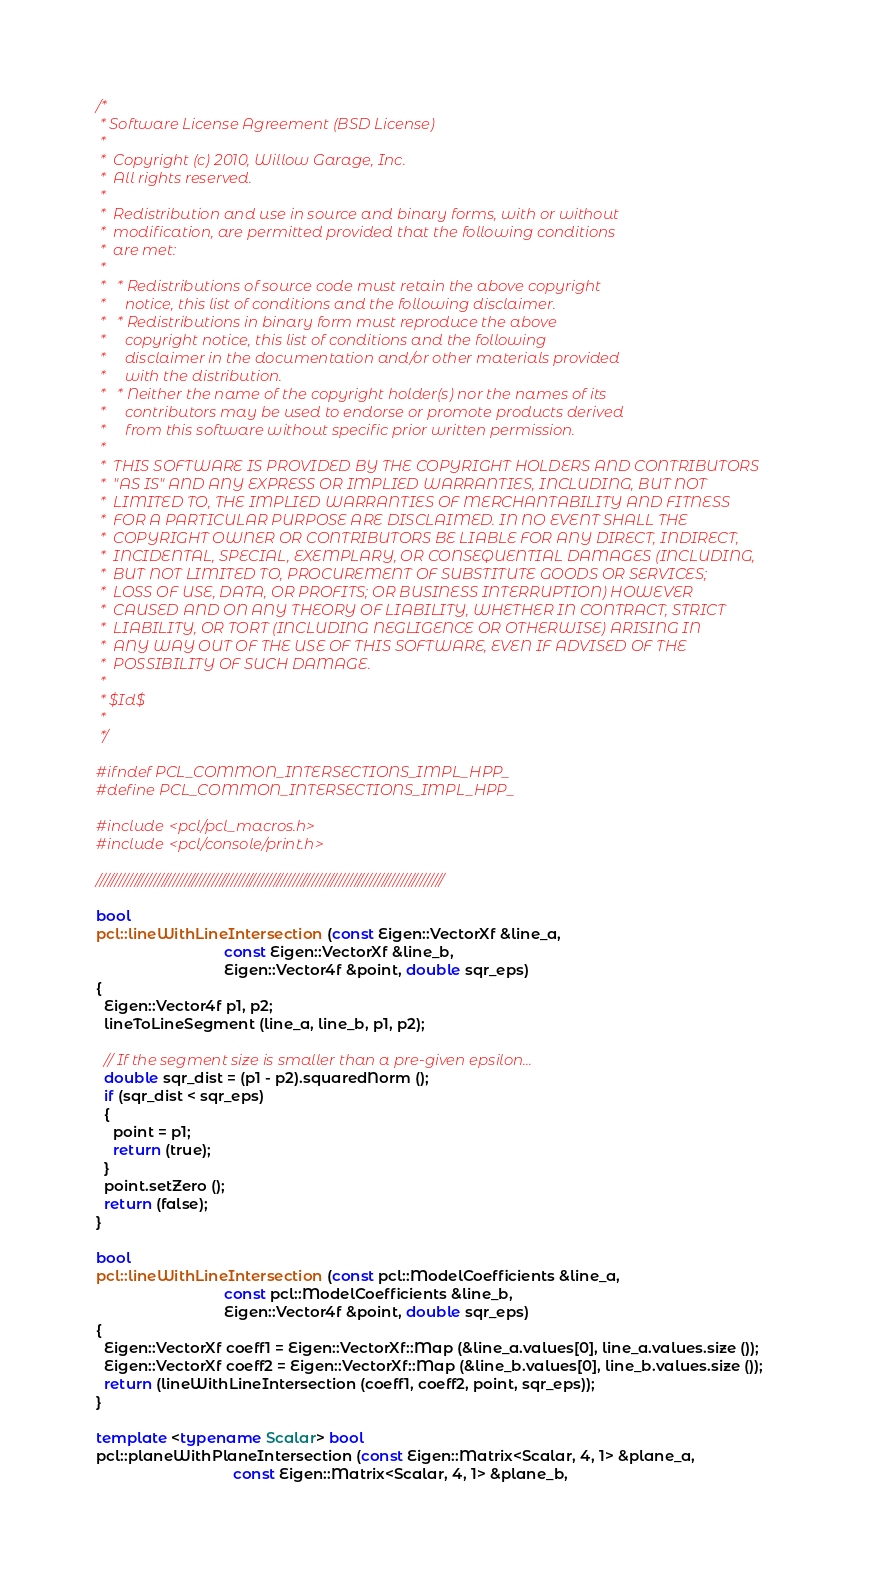Convert code to text. <code><loc_0><loc_0><loc_500><loc_500><_C++_>/*
 * Software License Agreement (BSD License)
 *
 *  Copyright (c) 2010, Willow Garage, Inc.
 *  All rights reserved.
 *
 *  Redistribution and use in source and binary forms, with or without
 *  modification, are permitted provided that the following conditions
 *  are met:
 *
 *   * Redistributions of source code must retain the above copyright
 *     notice, this list of conditions and the following disclaimer.
 *   * Redistributions in binary form must reproduce the above
 *     copyright notice, this list of conditions and the following
 *     disclaimer in the documentation and/or other materials provided
 *     with the distribution.
 *   * Neither the name of the copyright holder(s) nor the names of its
 *     contributors may be used to endorse or promote products derived
 *     from this software without specific prior written permission.
 *
 *  THIS SOFTWARE IS PROVIDED BY THE COPYRIGHT HOLDERS AND CONTRIBUTORS
 *  "AS IS" AND ANY EXPRESS OR IMPLIED WARRANTIES, INCLUDING, BUT NOT
 *  LIMITED TO, THE IMPLIED WARRANTIES OF MERCHANTABILITY AND FITNESS
 *  FOR A PARTICULAR PURPOSE ARE DISCLAIMED. IN NO EVENT SHALL THE
 *  COPYRIGHT OWNER OR CONTRIBUTORS BE LIABLE FOR ANY DIRECT, INDIRECT,
 *  INCIDENTAL, SPECIAL, EXEMPLARY, OR CONSEQUENTIAL DAMAGES (INCLUDING,
 *  BUT NOT LIMITED TO, PROCUREMENT OF SUBSTITUTE GOODS OR SERVICES;
 *  LOSS OF USE, DATA, OR PROFITS; OR BUSINESS INTERRUPTION) HOWEVER
 *  CAUSED AND ON ANY THEORY OF LIABILITY, WHETHER IN CONTRACT, STRICT
 *  LIABILITY, OR TORT (INCLUDING NEGLIGENCE OR OTHERWISE) ARISING IN
 *  ANY WAY OUT OF THE USE OF THIS SOFTWARE, EVEN IF ADVISED OF THE
 *  POSSIBILITY OF SUCH DAMAGE.
 *
 * $Id$
 *
 */

#ifndef PCL_COMMON_INTERSECTIONS_IMPL_HPP_
#define PCL_COMMON_INTERSECTIONS_IMPL_HPP_

#include <pcl/pcl_macros.h>
#include <pcl/console/print.h>

//////////////////////////////////////////////////////////////////////////////////////////

bool
pcl::lineWithLineIntersection (const Eigen::VectorXf &line_a, 
                               const Eigen::VectorXf &line_b, 
                               Eigen::Vector4f &point, double sqr_eps)
{
  Eigen::Vector4f p1, p2;
  lineToLineSegment (line_a, line_b, p1, p2);

  // If the segment size is smaller than a pre-given epsilon...
  double sqr_dist = (p1 - p2).squaredNorm ();
  if (sqr_dist < sqr_eps)
  {
    point = p1;
    return (true);
  }
  point.setZero ();
  return (false);
}

bool
pcl::lineWithLineIntersection (const pcl::ModelCoefficients &line_a, 
                               const pcl::ModelCoefficients &line_b, 
                               Eigen::Vector4f &point, double sqr_eps)
{
  Eigen::VectorXf coeff1 = Eigen::VectorXf::Map (&line_a.values[0], line_a.values.size ());
  Eigen::VectorXf coeff2 = Eigen::VectorXf::Map (&line_b.values[0], line_b.values.size ());
  return (lineWithLineIntersection (coeff1, coeff2, point, sqr_eps));
}

template <typename Scalar> bool 
pcl::planeWithPlaneIntersection (const Eigen::Matrix<Scalar, 4, 1> &plane_a, 
                                 const Eigen::Matrix<Scalar, 4, 1> &plane_b,</code> 